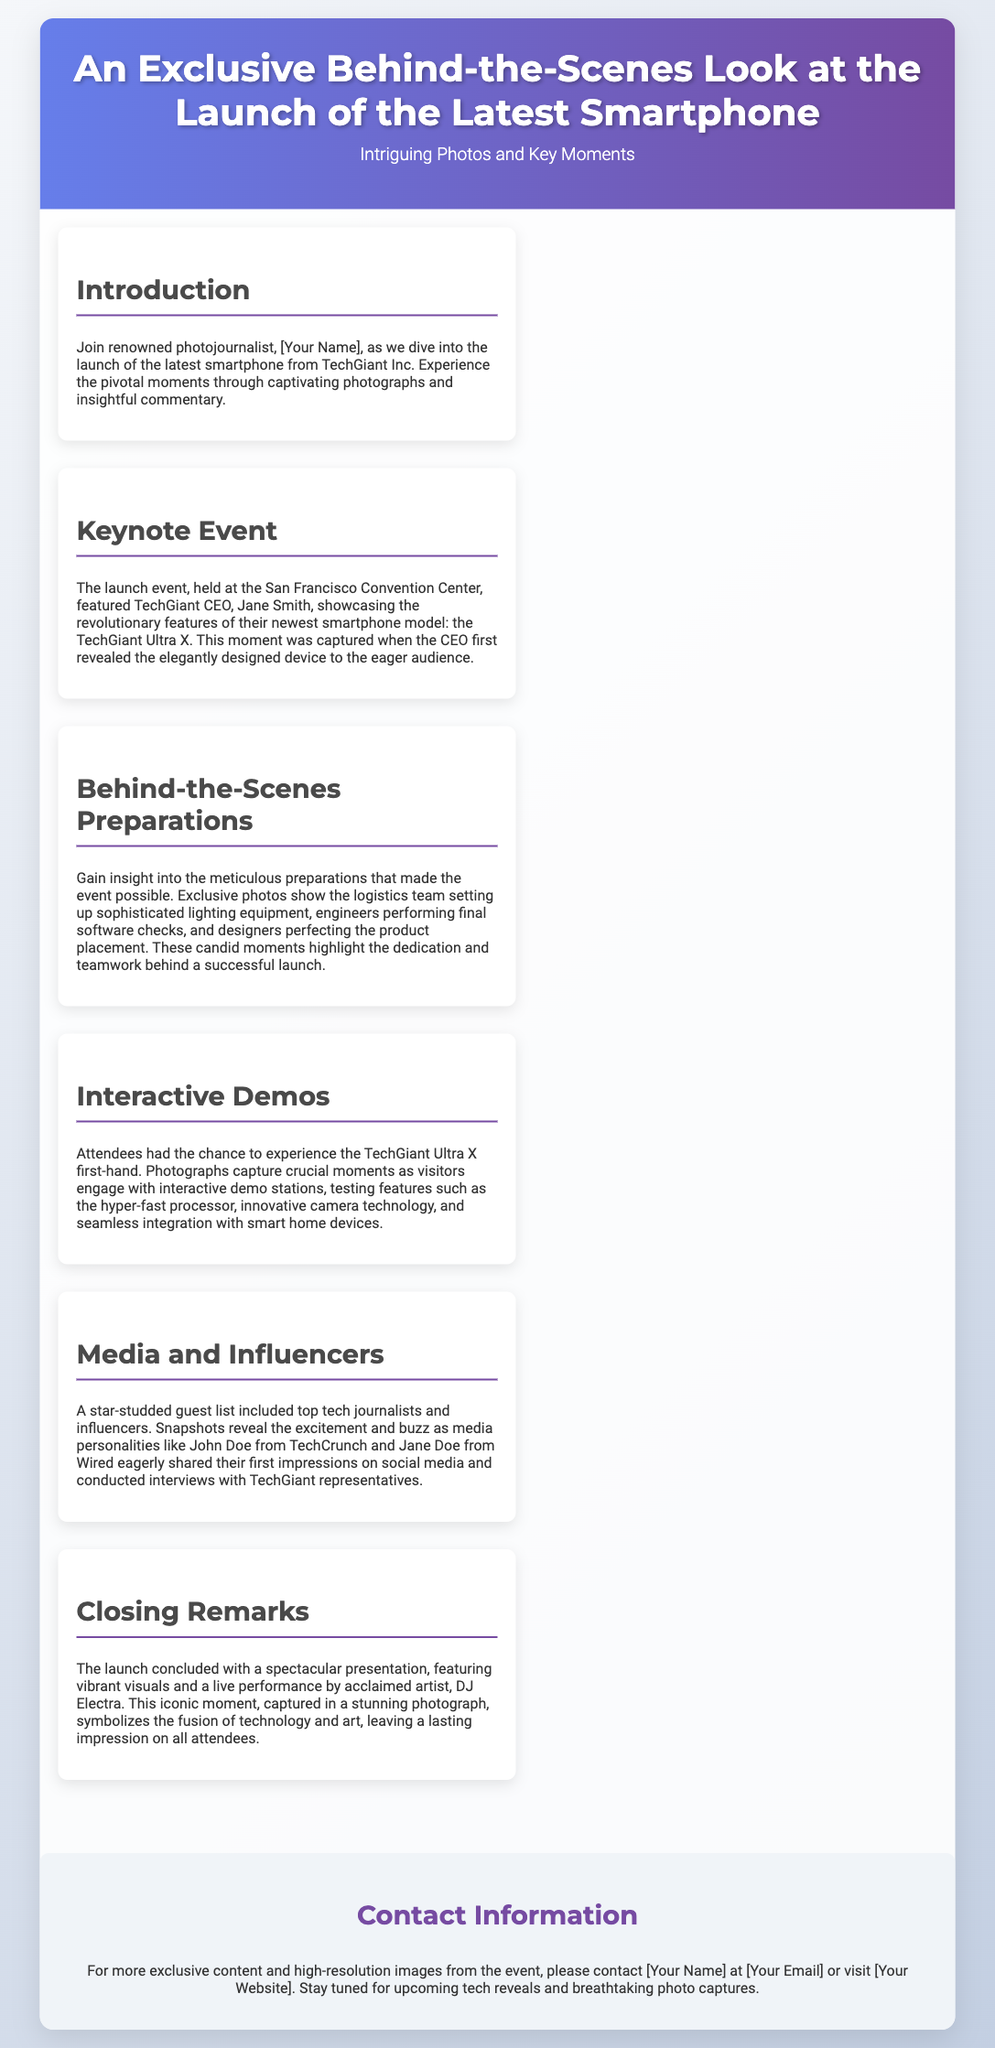What is the name of the latest smartphone launched? The document states that the newest smartphone model is called the TechGiant Ultra X.
Answer: TechGiant Ultra X Who is the CEO of TechGiant Inc.? The document mentions that the CEO showcasing the features is Jane Smith.
Answer: Jane Smith Where was the launch event held? According to the document, the launch event took place at the San Francisco Convention Center.
Answer: San Francisco Convention Center What did the closing presentation feature? The document indicates that the closing remarks included a live performance by DJ Electra.
Answer: DJ Electra What type of attendees were present at the event? The document reveals that top tech journalists and influencers were part of the guest list.
Answer: Tech journalists and influencers What was a significant moment captured during the keynote event? It was noted that a pivotal moment was when the CEO first revealed the device to the audience.
Answer: The CEO first revealed the device How were the event preparations characterized? The document highlights that the preparations were meticulous and involved teamwork.
Answer: Meticulous preparations What feature of the smartphone was highlighted during interactive demos? The document states that the hyper-fast processor was tested at the demo stations.
Answer: Hyper-fast processor What symbolized the fusion of technology and art at the event? The document claims that the iconic moment captured during the closing remarks represents this fusion.
Answer: Closing remarks presentation 